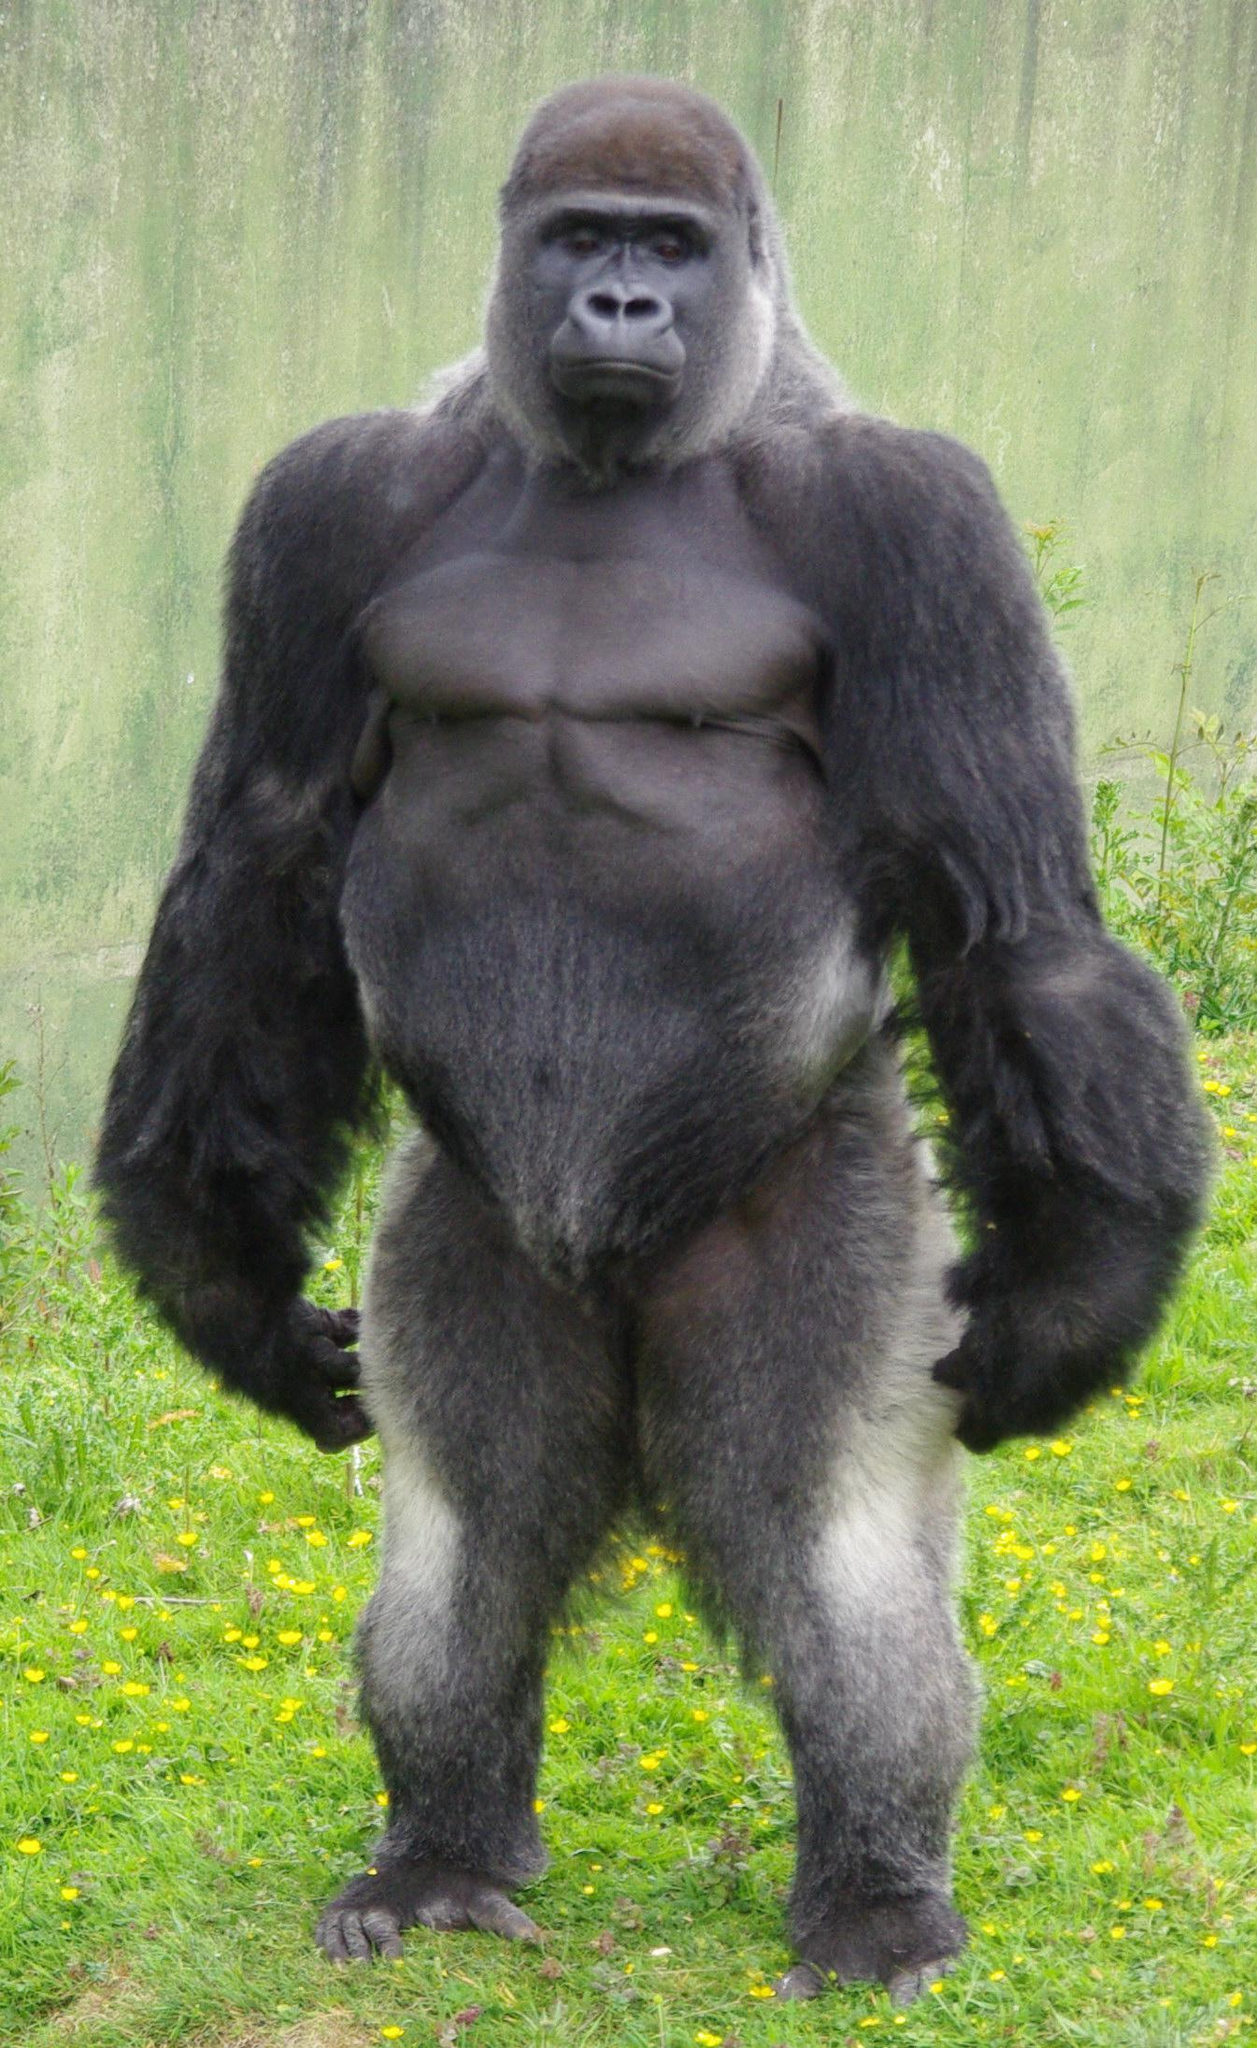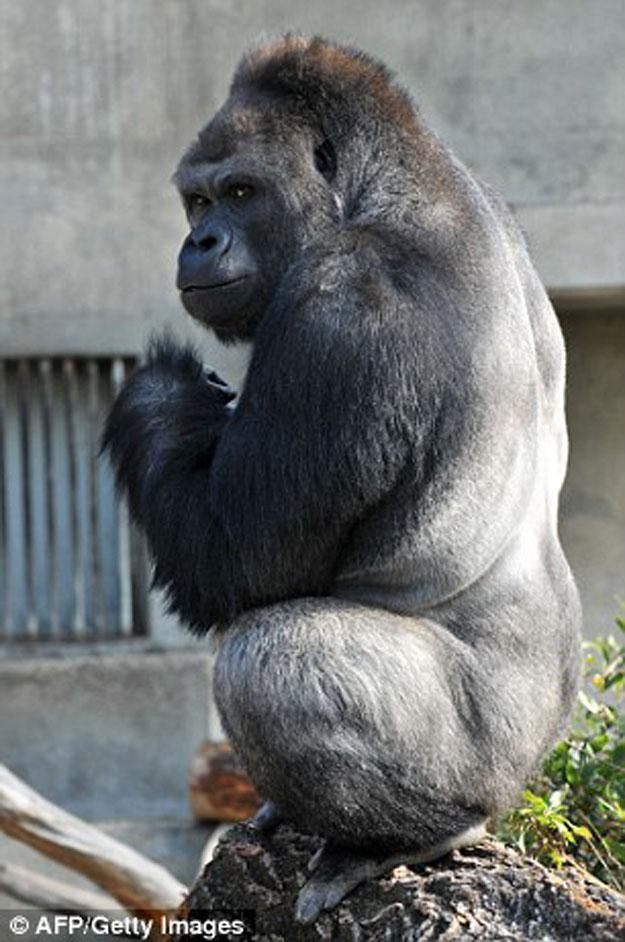The first image is the image on the left, the second image is the image on the right. For the images shown, is this caption "One image shows a gorilla standing up straight, and the other shows a gorilla turning its head to eye the camera, with one elbow bent and hand near its chin." true? Answer yes or no. Yes. The first image is the image on the left, the second image is the image on the right. Assess this claim about the two images: "A concrete barrier can be seen behind the ape in the image on the left.". Correct or not? Answer yes or no. Yes. 